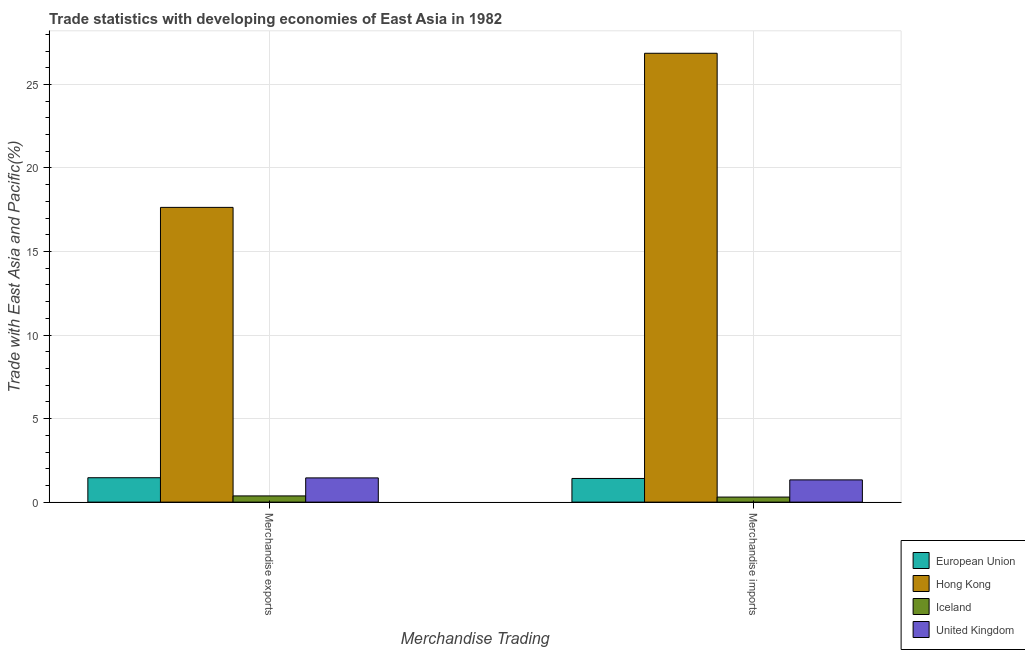How many different coloured bars are there?
Ensure brevity in your answer.  4. How many groups of bars are there?
Provide a succinct answer. 2. How many bars are there on the 1st tick from the left?
Provide a succinct answer. 4. How many bars are there on the 1st tick from the right?
Your response must be concise. 4. What is the merchandise exports in Iceland?
Provide a short and direct response. 0.37. Across all countries, what is the maximum merchandise exports?
Offer a very short reply. 17.64. Across all countries, what is the minimum merchandise imports?
Provide a short and direct response. 0.3. In which country was the merchandise imports maximum?
Your answer should be compact. Hong Kong. In which country was the merchandise exports minimum?
Provide a short and direct response. Iceland. What is the total merchandise exports in the graph?
Keep it short and to the point. 20.92. What is the difference between the merchandise imports in European Union and that in United Kingdom?
Your response must be concise. 0.08. What is the difference between the merchandise exports in Iceland and the merchandise imports in European Union?
Ensure brevity in your answer.  -1.04. What is the average merchandise exports per country?
Your answer should be very brief. 5.23. What is the difference between the merchandise exports and merchandise imports in United Kingdom?
Your response must be concise. 0.12. In how many countries, is the merchandise exports greater than 27 %?
Your response must be concise. 0. What is the ratio of the merchandise imports in United Kingdom to that in Iceland?
Provide a short and direct response. 4.4. Is the merchandise imports in Iceland less than that in European Union?
Keep it short and to the point. Yes. In how many countries, is the merchandise exports greater than the average merchandise exports taken over all countries?
Keep it short and to the point. 1. What does the 4th bar from the left in Merchandise imports represents?
Your answer should be very brief. United Kingdom. Are all the bars in the graph horizontal?
Give a very brief answer. No. What is the difference between two consecutive major ticks on the Y-axis?
Ensure brevity in your answer.  5. Are the values on the major ticks of Y-axis written in scientific E-notation?
Provide a short and direct response. No. Does the graph contain any zero values?
Keep it short and to the point. No. Does the graph contain grids?
Provide a succinct answer. Yes. Where does the legend appear in the graph?
Your response must be concise. Bottom right. How many legend labels are there?
Make the answer very short. 4. What is the title of the graph?
Offer a very short reply. Trade statistics with developing economies of East Asia in 1982. Does "High income: OECD" appear as one of the legend labels in the graph?
Your response must be concise. No. What is the label or title of the X-axis?
Provide a succinct answer. Merchandise Trading. What is the label or title of the Y-axis?
Provide a short and direct response. Trade with East Asia and Pacific(%). What is the Trade with East Asia and Pacific(%) of European Union in Merchandise exports?
Make the answer very short. 1.46. What is the Trade with East Asia and Pacific(%) of Hong Kong in Merchandise exports?
Make the answer very short. 17.64. What is the Trade with East Asia and Pacific(%) of Iceland in Merchandise exports?
Offer a terse response. 0.37. What is the Trade with East Asia and Pacific(%) in United Kingdom in Merchandise exports?
Give a very brief answer. 1.45. What is the Trade with East Asia and Pacific(%) of European Union in Merchandise imports?
Your answer should be very brief. 1.42. What is the Trade with East Asia and Pacific(%) in Hong Kong in Merchandise imports?
Provide a succinct answer. 26.87. What is the Trade with East Asia and Pacific(%) of Iceland in Merchandise imports?
Give a very brief answer. 0.3. What is the Trade with East Asia and Pacific(%) of United Kingdom in Merchandise imports?
Keep it short and to the point. 1.33. Across all Merchandise Trading, what is the maximum Trade with East Asia and Pacific(%) in European Union?
Provide a succinct answer. 1.46. Across all Merchandise Trading, what is the maximum Trade with East Asia and Pacific(%) in Hong Kong?
Keep it short and to the point. 26.87. Across all Merchandise Trading, what is the maximum Trade with East Asia and Pacific(%) of Iceland?
Give a very brief answer. 0.37. Across all Merchandise Trading, what is the maximum Trade with East Asia and Pacific(%) in United Kingdom?
Ensure brevity in your answer.  1.45. Across all Merchandise Trading, what is the minimum Trade with East Asia and Pacific(%) in European Union?
Your answer should be compact. 1.42. Across all Merchandise Trading, what is the minimum Trade with East Asia and Pacific(%) of Hong Kong?
Ensure brevity in your answer.  17.64. Across all Merchandise Trading, what is the minimum Trade with East Asia and Pacific(%) of Iceland?
Keep it short and to the point. 0.3. Across all Merchandise Trading, what is the minimum Trade with East Asia and Pacific(%) in United Kingdom?
Provide a succinct answer. 1.33. What is the total Trade with East Asia and Pacific(%) in European Union in the graph?
Give a very brief answer. 2.88. What is the total Trade with East Asia and Pacific(%) in Hong Kong in the graph?
Your answer should be compact. 44.51. What is the total Trade with East Asia and Pacific(%) in Iceland in the graph?
Your response must be concise. 0.67. What is the total Trade with East Asia and Pacific(%) of United Kingdom in the graph?
Ensure brevity in your answer.  2.78. What is the difference between the Trade with East Asia and Pacific(%) of European Union in Merchandise exports and that in Merchandise imports?
Offer a terse response. 0.04. What is the difference between the Trade with East Asia and Pacific(%) of Hong Kong in Merchandise exports and that in Merchandise imports?
Keep it short and to the point. -9.22. What is the difference between the Trade with East Asia and Pacific(%) in Iceland in Merchandise exports and that in Merchandise imports?
Your answer should be compact. 0.07. What is the difference between the Trade with East Asia and Pacific(%) of United Kingdom in Merchandise exports and that in Merchandise imports?
Give a very brief answer. 0.12. What is the difference between the Trade with East Asia and Pacific(%) of European Union in Merchandise exports and the Trade with East Asia and Pacific(%) of Hong Kong in Merchandise imports?
Make the answer very short. -25.41. What is the difference between the Trade with East Asia and Pacific(%) in European Union in Merchandise exports and the Trade with East Asia and Pacific(%) in Iceland in Merchandise imports?
Provide a succinct answer. 1.16. What is the difference between the Trade with East Asia and Pacific(%) of European Union in Merchandise exports and the Trade with East Asia and Pacific(%) of United Kingdom in Merchandise imports?
Offer a terse response. 0.13. What is the difference between the Trade with East Asia and Pacific(%) in Hong Kong in Merchandise exports and the Trade with East Asia and Pacific(%) in Iceland in Merchandise imports?
Offer a terse response. 17.34. What is the difference between the Trade with East Asia and Pacific(%) in Hong Kong in Merchandise exports and the Trade with East Asia and Pacific(%) in United Kingdom in Merchandise imports?
Your response must be concise. 16.31. What is the difference between the Trade with East Asia and Pacific(%) in Iceland in Merchandise exports and the Trade with East Asia and Pacific(%) in United Kingdom in Merchandise imports?
Provide a succinct answer. -0.96. What is the average Trade with East Asia and Pacific(%) of European Union per Merchandise Trading?
Provide a short and direct response. 1.44. What is the average Trade with East Asia and Pacific(%) of Hong Kong per Merchandise Trading?
Keep it short and to the point. 22.25. What is the average Trade with East Asia and Pacific(%) of Iceland per Merchandise Trading?
Your answer should be very brief. 0.34. What is the average Trade with East Asia and Pacific(%) of United Kingdom per Merchandise Trading?
Offer a very short reply. 1.39. What is the difference between the Trade with East Asia and Pacific(%) in European Union and Trade with East Asia and Pacific(%) in Hong Kong in Merchandise exports?
Provide a short and direct response. -16.18. What is the difference between the Trade with East Asia and Pacific(%) of European Union and Trade with East Asia and Pacific(%) of Iceland in Merchandise exports?
Offer a very short reply. 1.09. What is the difference between the Trade with East Asia and Pacific(%) of European Union and Trade with East Asia and Pacific(%) of United Kingdom in Merchandise exports?
Ensure brevity in your answer.  0.01. What is the difference between the Trade with East Asia and Pacific(%) of Hong Kong and Trade with East Asia and Pacific(%) of Iceland in Merchandise exports?
Keep it short and to the point. 17.27. What is the difference between the Trade with East Asia and Pacific(%) in Hong Kong and Trade with East Asia and Pacific(%) in United Kingdom in Merchandise exports?
Provide a short and direct response. 16.19. What is the difference between the Trade with East Asia and Pacific(%) in Iceland and Trade with East Asia and Pacific(%) in United Kingdom in Merchandise exports?
Keep it short and to the point. -1.08. What is the difference between the Trade with East Asia and Pacific(%) in European Union and Trade with East Asia and Pacific(%) in Hong Kong in Merchandise imports?
Ensure brevity in your answer.  -25.45. What is the difference between the Trade with East Asia and Pacific(%) of European Union and Trade with East Asia and Pacific(%) of Iceland in Merchandise imports?
Offer a terse response. 1.11. What is the difference between the Trade with East Asia and Pacific(%) of European Union and Trade with East Asia and Pacific(%) of United Kingdom in Merchandise imports?
Your answer should be very brief. 0.08. What is the difference between the Trade with East Asia and Pacific(%) in Hong Kong and Trade with East Asia and Pacific(%) in Iceland in Merchandise imports?
Your answer should be compact. 26.56. What is the difference between the Trade with East Asia and Pacific(%) in Hong Kong and Trade with East Asia and Pacific(%) in United Kingdom in Merchandise imports?
Provide a succinct answer. 25.53. What is the difference between the Trade with East Asia and Pacific(%) of Iceland and Trade with East Asia and Pacific(%) of United Kingdom in Merchandise imports?
Your response must be concise. -1.03. What is the ratio of the Trade with East Asia and Pacific(%) of European Union in Merchandise exports to that in Merchandise imports?
Your answer should be very brief. 1.03. What is the ratio of the Trade with East Asia and Pacific(%) of Hong Kong in Merchandise exports to that in Merchandise imports?
Provide a short and direct response. 0.66. What is the ratio of the Trade with East Asia and Pacific(%) in Iceland in Merchandise exports to that in Merchandise imports?
Make the answer very short. 1.23. What is the ratio of the Trade with East Asia and Pacific(%) in United Kingdom in Merchandise exports to that in Merchandise imports?
Make the answer very short. 1.09. What is the difference between the highest and the second highest Trade with East Asia and Pacific(%) of European Union?
Provide a short and direct response. 0.04. What is the difference between the highest and the second highest Trade with East Asia and Pacific(%) of Hong Kong?
Your response must be concise. 9.22. What is the difference between the highest and the second highest Trade with East Asia and Pacific(%) in Iceland?
Your response must be concise. 0.07. What is the difference between the highest and the second highest Trade with East Asia and Pacific(%) of United Kingdom?
Provide a succinct answer. 0.12. What is the difference between the highest and the lowest Trade with East Asia and Pacific(%) of European Union?
Your response must be concise. 0.04. What is the difference between the highest and the lowest Trade with East Asia and Pacific(%) in Hong Kong?
Provide a short and direct response. 9.22. What is the difference between the highest and the lowest Trade with East Asia and Pacific(%) of Iceland?
Your answer should be very brief. 0.07. What is the difference between the highest and the lowest Trade with East Asia and Pacific(%) of United Kingdom?
Provide a short and direct response. 0.12. 